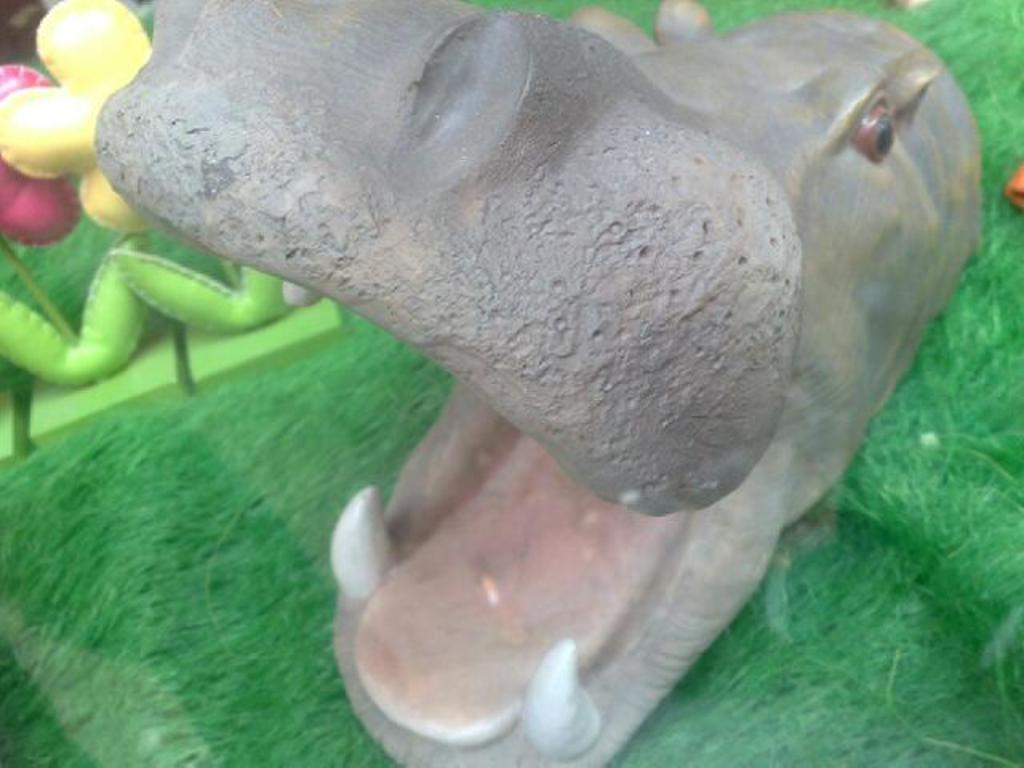What is the main subject of the image? The main subject of the image is an animal face. What color is the surface on which the animal face is located? The animal face is on a green surface. What type of behavior can be observed in the animal face in the image? There is no behavior to observe in the animal face, as it is a static image. How does the animal face hear sounds in the image? The animal face does not have the ability to hear sounds, as it is a static image. 